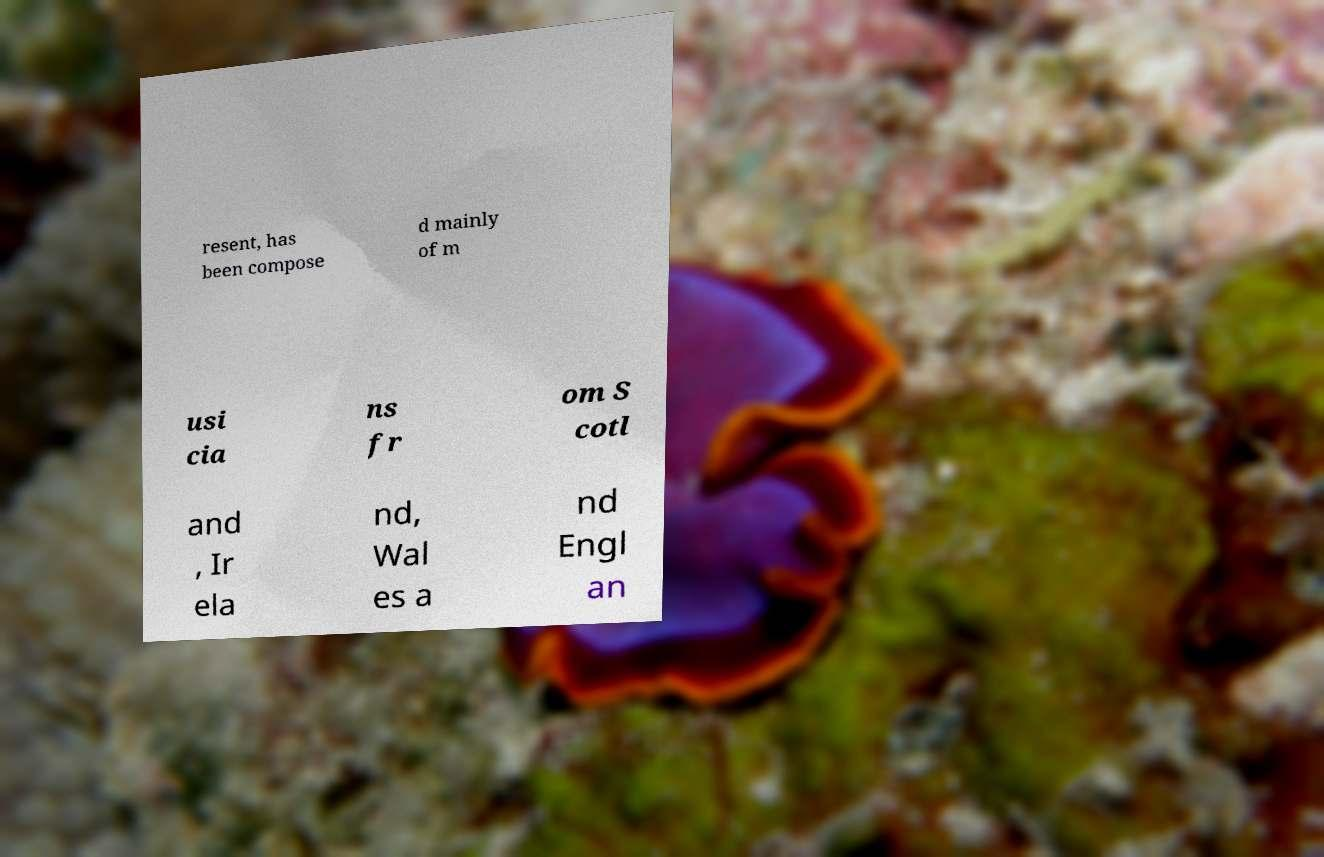Could you extract and type out the text from this image? resent, has been compose d mainly of m usi cia ns fr om S cotl and , Ir ela nd, Wal es a nd Engl an 